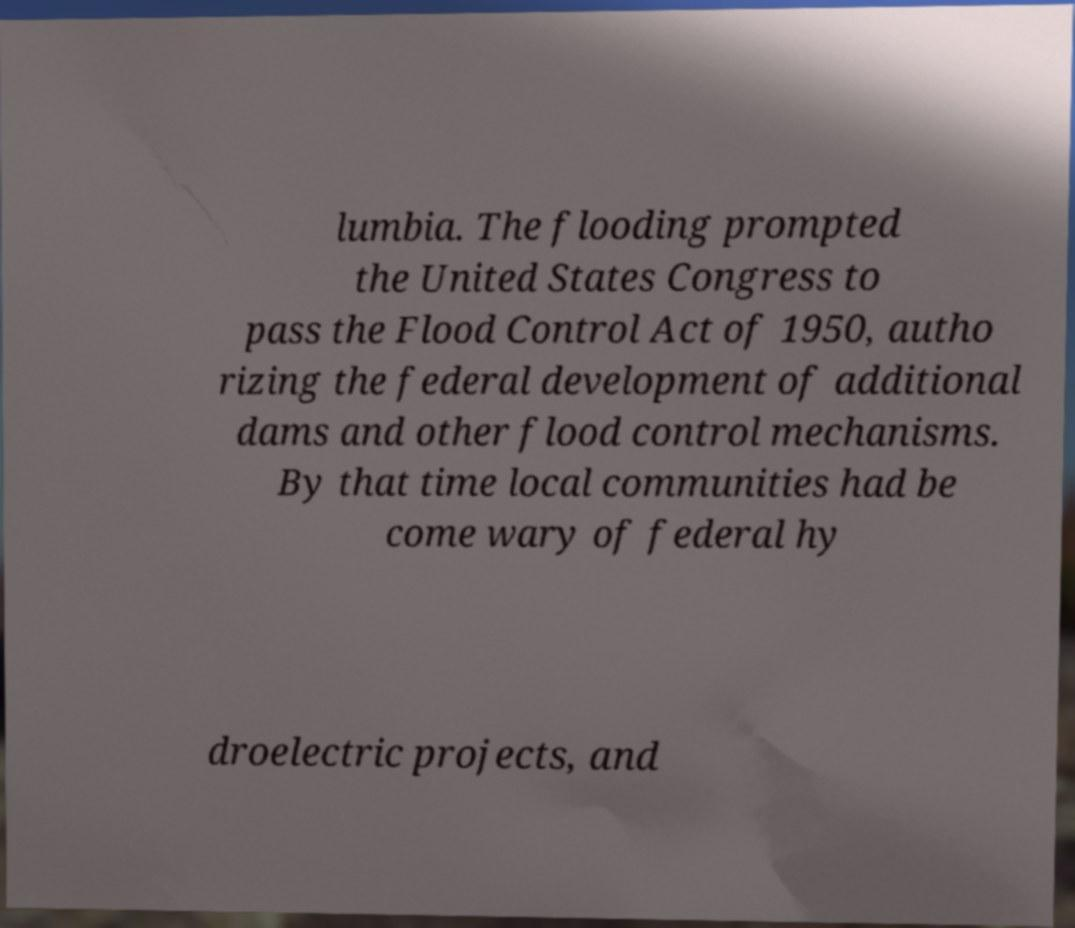I need the written content from this picture converted into text. Can you do that? lumbia. The flooding prompted the United States Congress to pass the Flood Control Act of 1950, autho rizing the federal development of additional dams and other flood control mechanisms. By that time local communities had be come wary of federal hy droelectric projects, and 